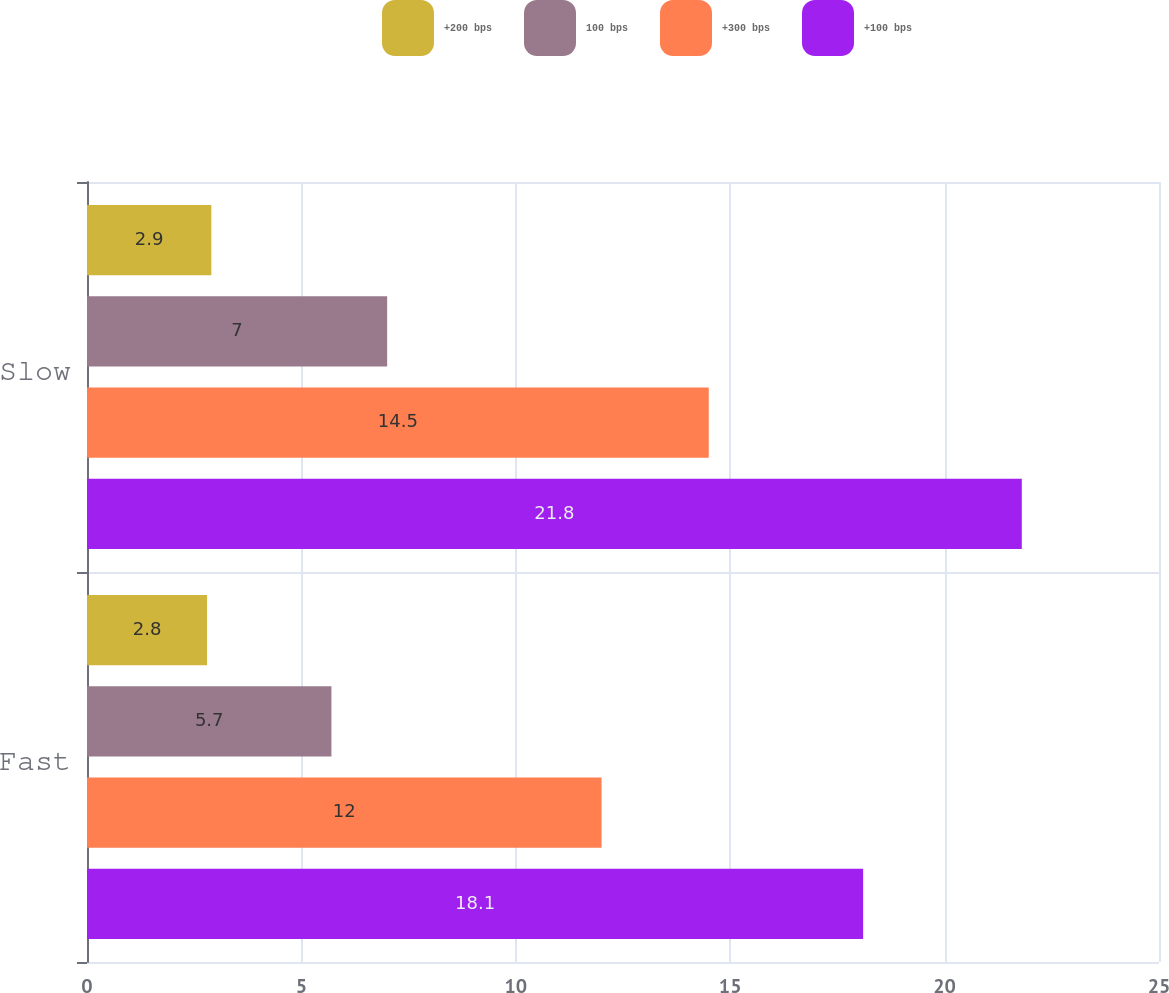Convert chart to OTSL. <chart><loc_0><loc_0><loc_500><loc_500><stacked_bar_chart><ecel><fcel>Fast<fcel>Slow<nl><fcel>+200 bps<fcel>2.8<fcel>2.9<nl><fcel>100 bps<fcel>5.7<fcel>7<nl><fcel>+300 bps<fcel>12<fcel>14.5<nl><fcel>+100 bps<fcel>18.1<fcel>21.8<nl></chart> 